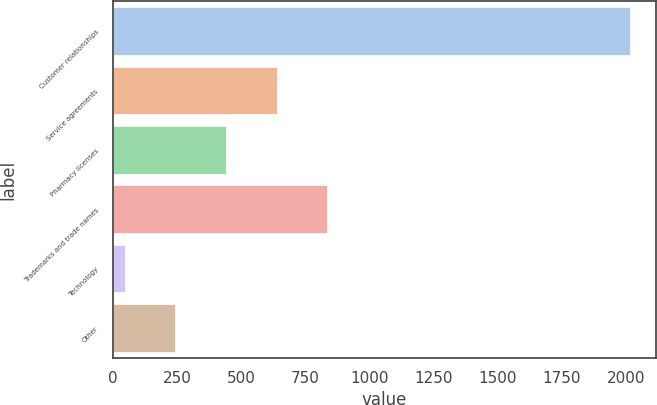<chart> <loc_0><loc_0><loc_500><loc_500><bar_chart><fcel>Customer relationships<fcel>Service agreements<fcel>Pharmacy licenses<fcel>Trademarks and trade names<fcel>Technology<fcel>Other<nl><fcel>2017<fcel>638<fcel>441<fcel>835<fcel>47<fcel>244<nl></chart> 